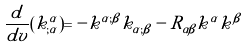Convert formula to latex. <formula><loc_0><loc_0><loc_500><loc_500>\frac { d } { d v } ( k ^ { \alpha } _ { ; \alpha } ) = - k ^ { \alpha ; \beta } k _ { \alpha ; \beta } - R _ { \alpha \beta } k ^ { \alpha } k ^ { \beta }</formula> 